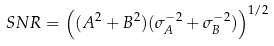Convert formula to latex. <formula><loc_0><loc_0><loc_500><loc_500>S N R = \left ( ( A ^ { 2 } + B ^ { 2 } ) ( \sigma _ { A } ^ { - 2 } + \sigma _ { B } ^ { - 2 } ) \right ) ^ { 1 / 2 }</formula> 